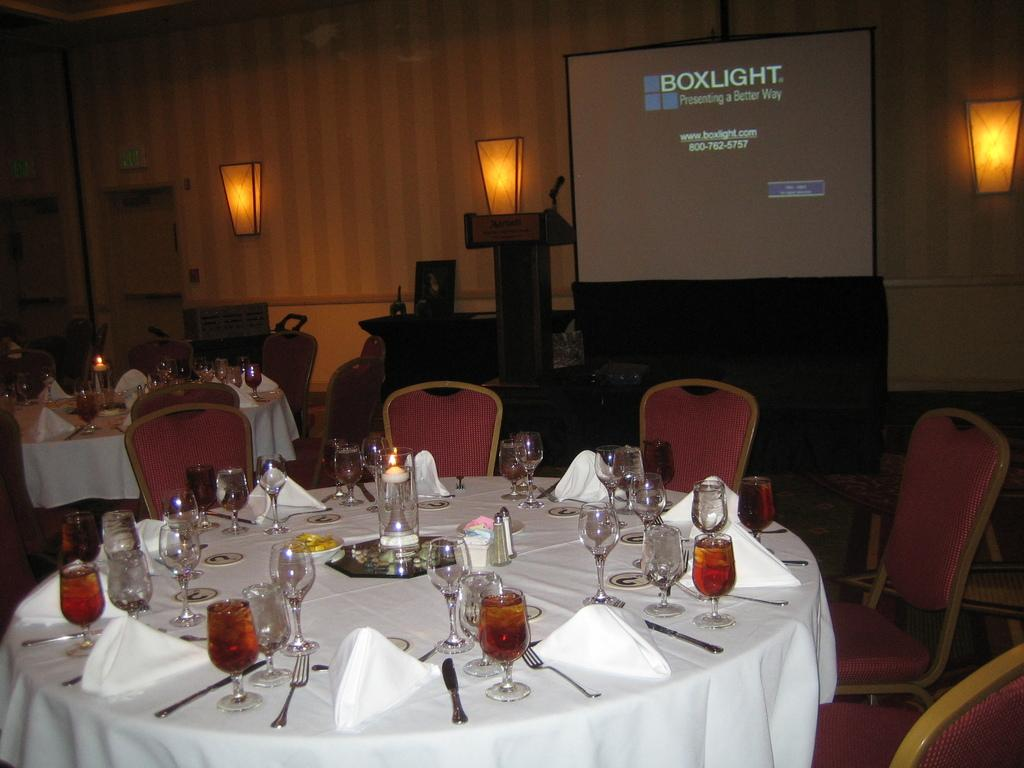<image>
Write a terse but informative summary of the picture. The presentation is about boxlight in this conference room. 